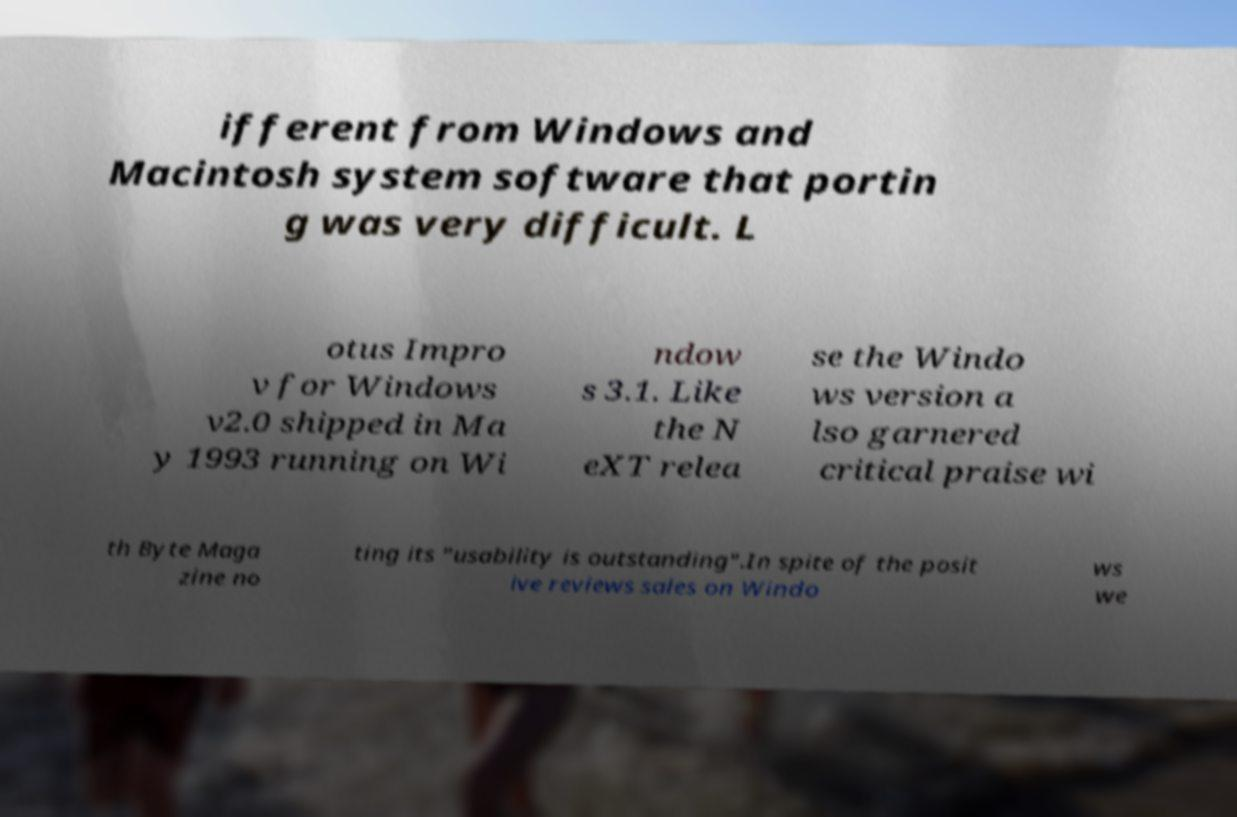Please identify and transcribe the text found in this image. ifferent from Windows and Macintosh system software that portin g was very difficult. L otus Impro v for Windows v2.0 shipped in Ma y 1993 running on Wi ndow s 3.1. Like the N eXT relea se the Windo ws version a lso garnered critical praise wi th Byte Maga zine no ting its "usability is outstanding".In spite of the posit ive reviews sales on Windo ws we 